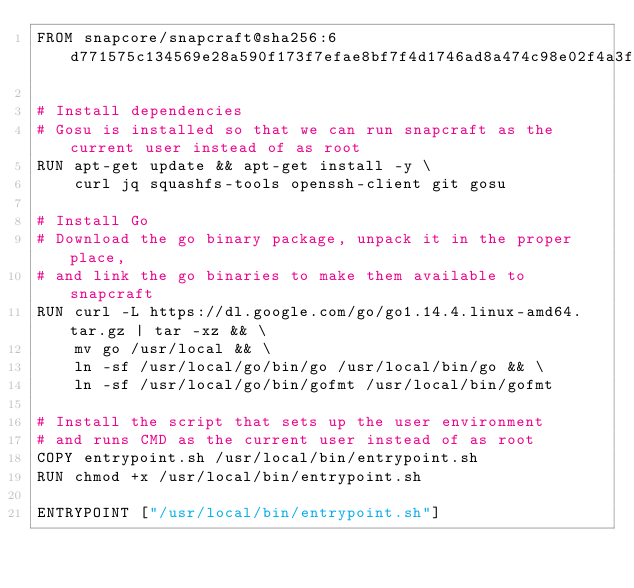<code> <loc_0><loc_0><loc_500><loc_500><_Dockerfile_>FROM snapcore/snapcraft@sha256:6d771575c134569e28a590f173f7efae8bf7f4d1746ad8a474c98e02f4a3f627

# Install dependencies
# Gosu is installed so that we can run snapcraft as the current user instead of as root
RUN apt-get update && apt-get install -y \
	curl jq squashfs-tools openssh-client git gosu

# Install Go
# Download the go binary package, unpack it in the proper place,
# and link the go binaries to make them available to snapcraft
RUN curl -L https://dl.google.com/go/go1.14.4.linux-amd64.tar.gz | tar -xz && \
    mv go /usr/local && \
    ln -sf /usr/local/go/bin/go /usr/local/bin/go && \
    ln -sf /usr/local/go/bin/gofmt /usr/local/bin/gofmt

# Install the script that sets up the user environment
# and runs CMD as the current user instead of as root
COPY entrypoint.sh /usr/local/bin/entrypoint.sh
RUN chmod +x /usr/local/bin/entrypoint.sh

ENTRYPOINT ["/usr/local/bin/entrypoint.sh"]
</code> 